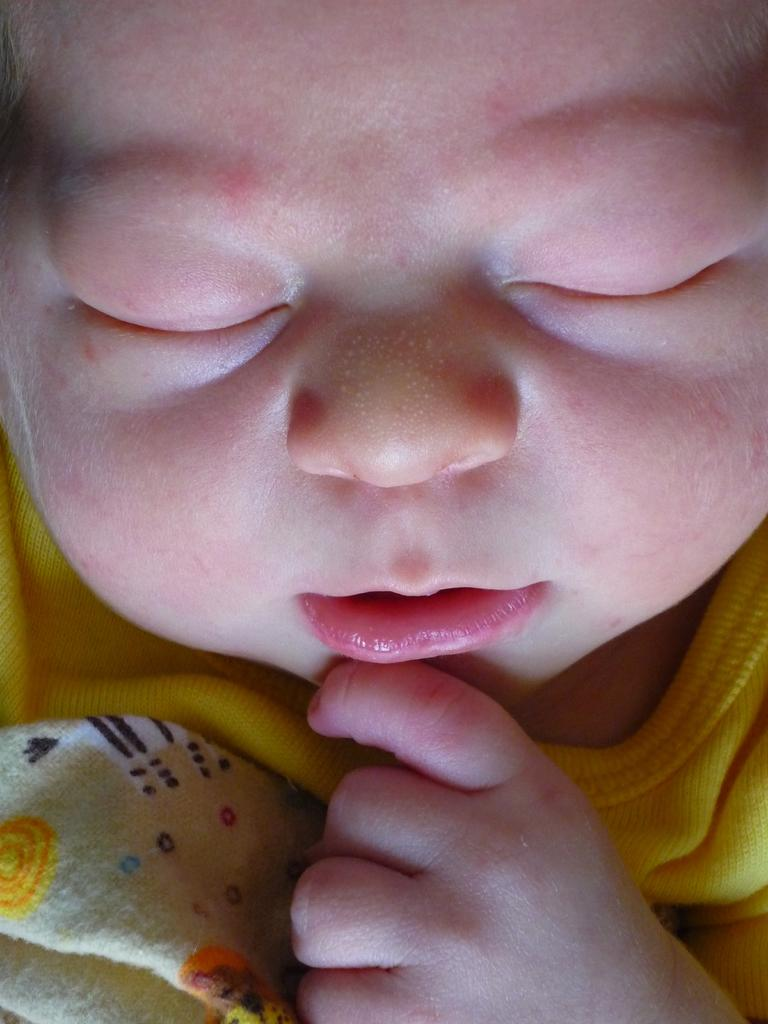What is the main subject of the image? There is a baby in the image. What type of steel structure can be seen supporting the bird in the image? There is no steel structure or bird present in the image; it only features a baby. 